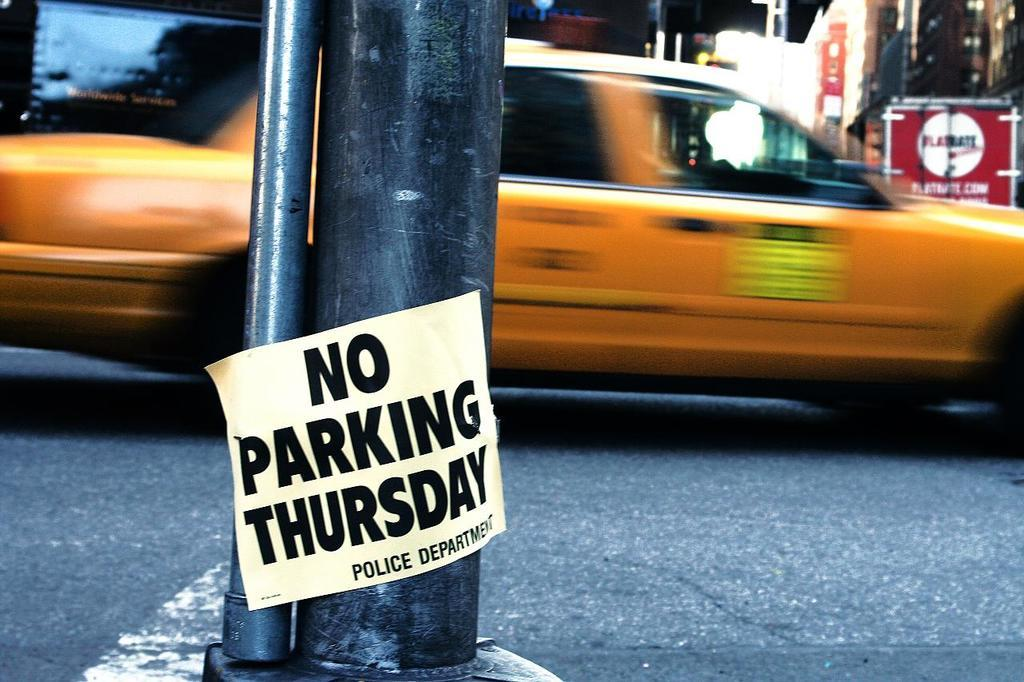<image>
Render a clear and concise summary of the photo. A black metal pole has a sign saying "no parking thursday" on the bottom 